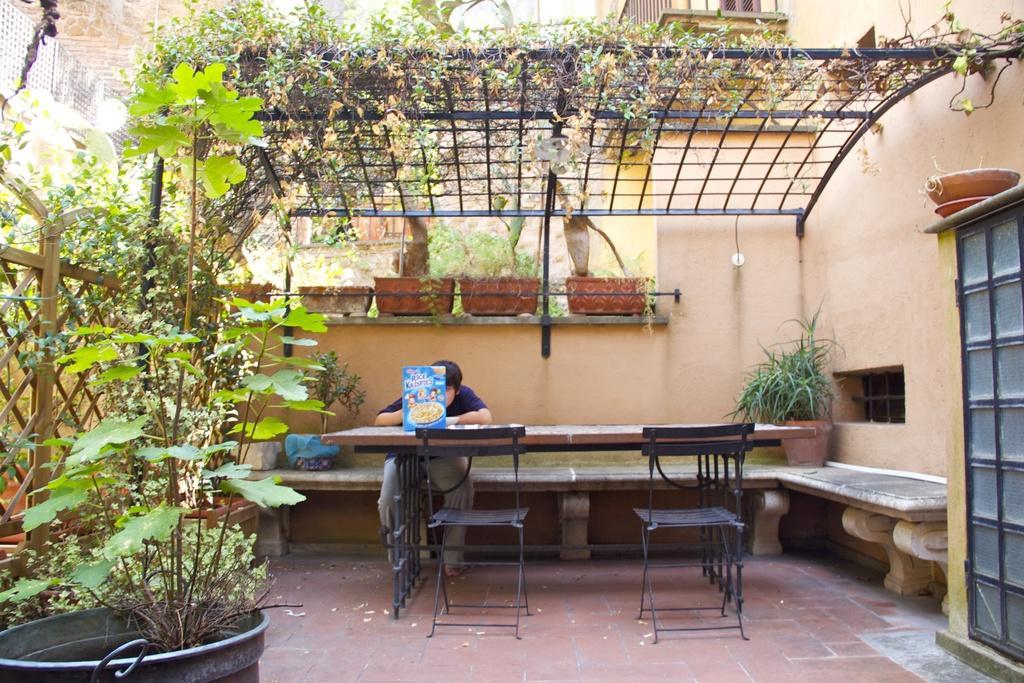Describe this image in one or two sentences. This is the picture of a place where we have a person sitting on the chair in front of the table and around him there are some plants and a shelf. 